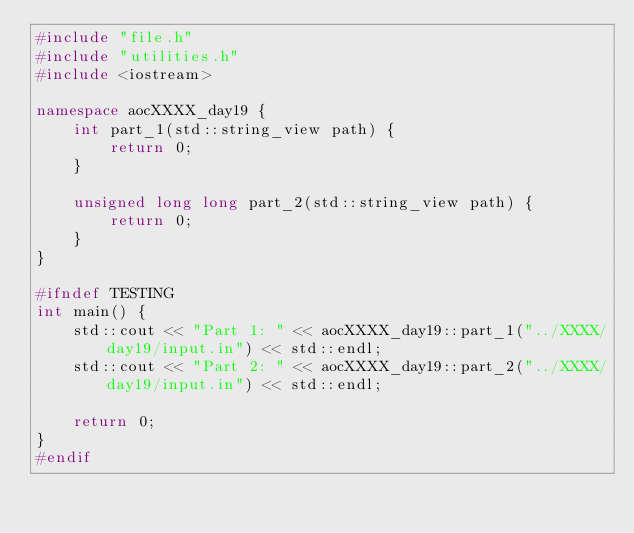<code> <loc_0><loc_0><loc_500><loc_500><_C++_>#include "file.h"
#include "utilities.h"
#include <iostream>

namespace aocXXXX_day19 {
    int part_1(std::string_view path) {
        return 0;
    }

    unsigned long long part_2(std::string_view path) {
        return 0;
    }
}

#ifndef TESTING
int main() {
    std::cout << "Part 1: " << aocXXXX_day19::part_1("../XXXX/day19/input.in") << std::endl;
    std::cout << "Part 2: " << aocXXXX_day19::part_2("../XXXX/day19/input.in") << std::endl;

    return 0;
}
#endif
</code> 